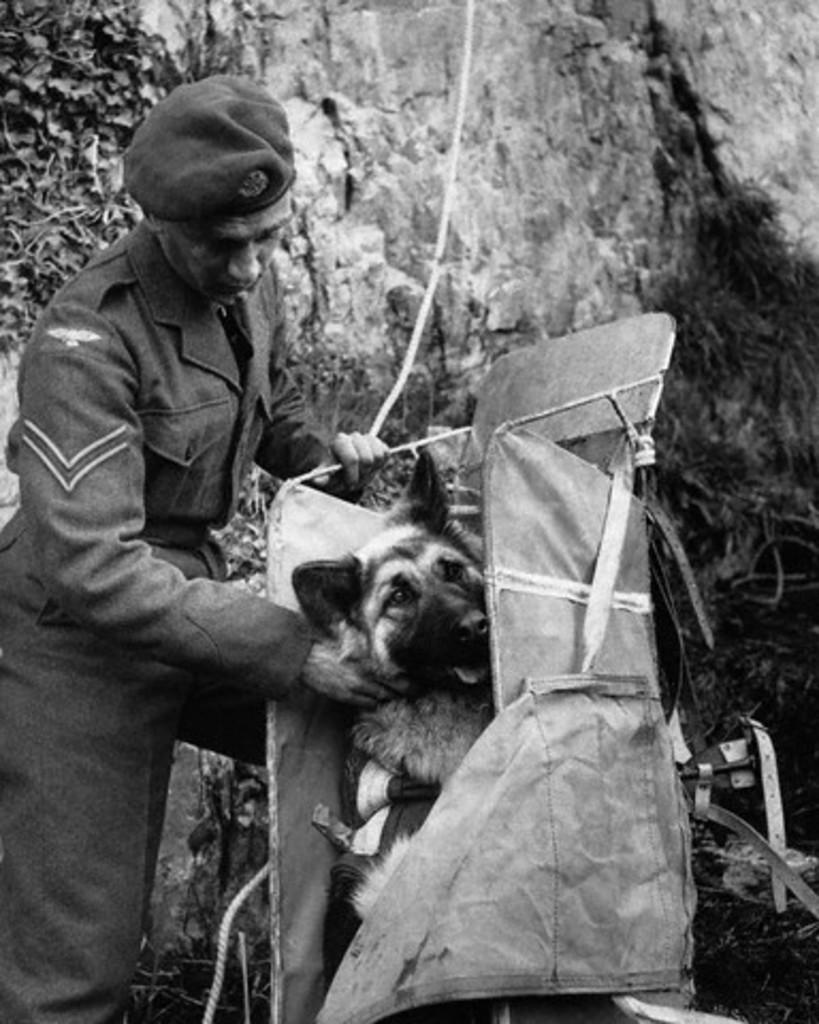Please provide a concise description of this image. In this picture we can see a man standing and holding a dog which is in the bag, in the background we can find a rock, man is wearing a uniform with cap. 